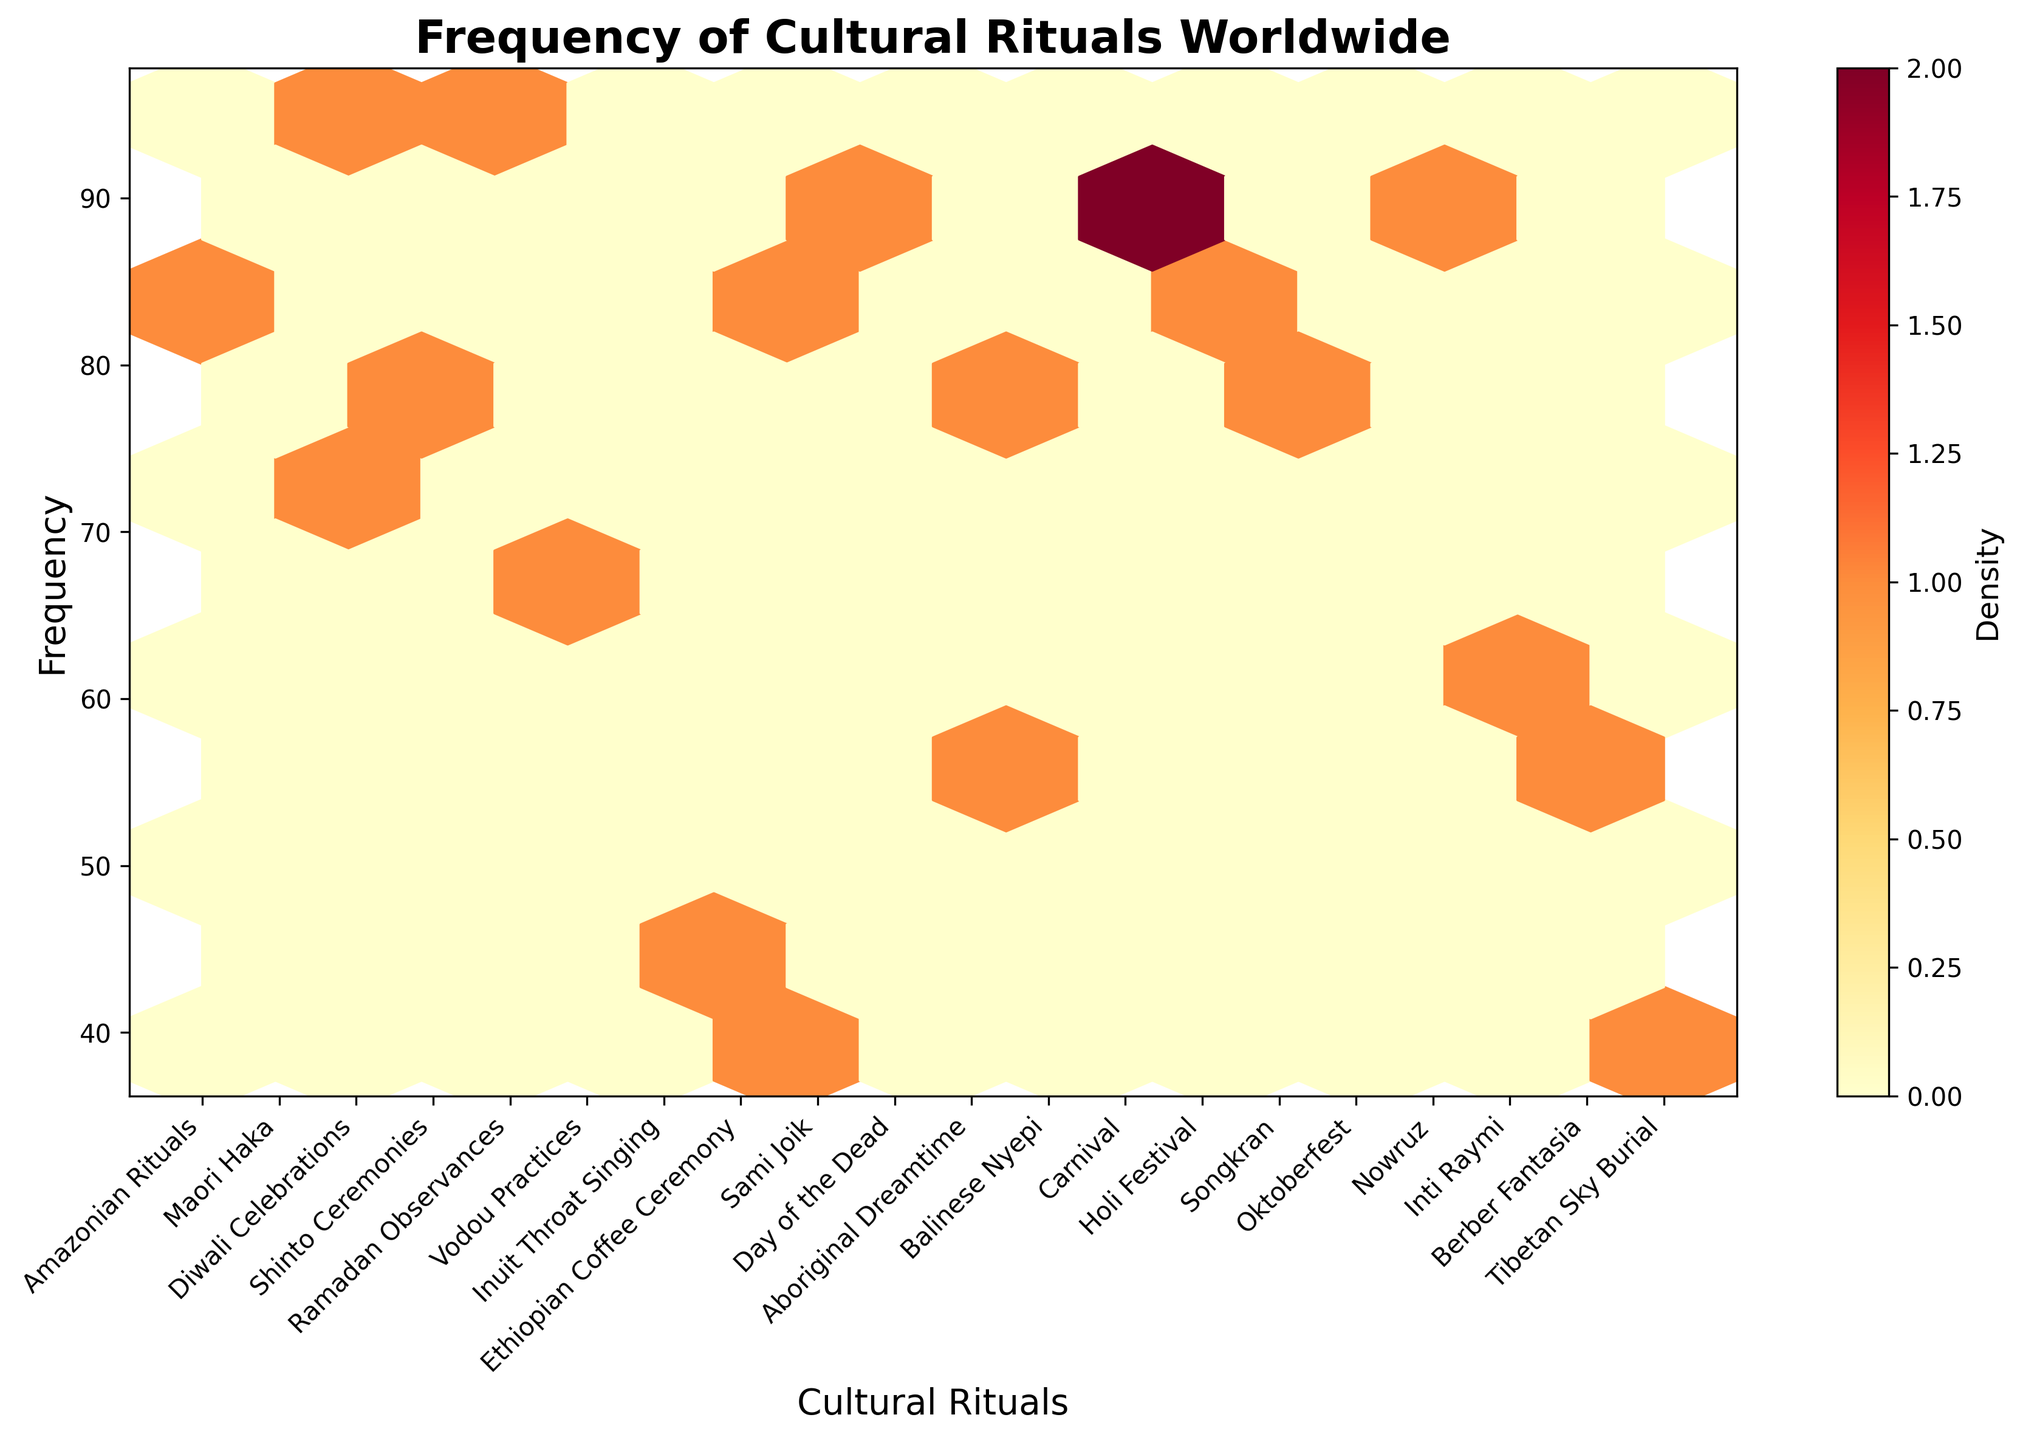what is the title of the plot? The plot has a title positioned at the top, which helps the viewer understand the purpose of the visualization.
Answer: Frequency of Cultural Rituals Worldwide which cultural ritual has the highest frequency? The frequency of each cultural ritual is plotted on the y-axis. By looking at the highest point on this axis, we can identify the cultural ritual with the highest frequency.
Answer: Diwali Celebrations how many rituals have a frequency greater than 80? You need to count all the cultural rituals whose y-values (frequencies) are greater than 80. These are represented as points above the y=80 line on the plot.
Answer: 9 what is the frequency difference between the Maori Haka and Inuit Throat Singing? To find the difference, first identify the y-values (frequencies) for both rituals, then subtract the smaller value from the larger value. Maori Haka has a frequency of 72 and Inuit Throat Singing has a frequency of 45; so the difference is 72 - 45.
Answer: 27 which cultural rituals are represented from Oceania, and what are their frequencies? From the xtick labels, identify the rituals associated with Oceania and then note their frequencies from the y-axis.
Answer: Maori Haka (72) and Aboriginal Dreamtime (57) how does the frequency of 'Vodou Practices' compare to 'Day of the Dead'? Identify the y-values (frequencies) for both rituals. Vodou Practices have a frequency of 68 and Day of the Dead has a frequency of 88. Comparatively, Day of the Dead has a higher frequency.
Answer: Day of the Dead has a higher frequency than Vodou Practices what is the average frequency of Central Asia's and Middle East's rituals? Identify the frequencies for Central Asia's and Middle East's rituals from the xtick labels and y-values, then sum them up and divide by the number of rituals. Nowruz (86), Tibetan Sky Burial (41), and Ramadan Observances (93). The average is (86 + 41 + 93) / 3.
Answer: 73.33 among South American rituals, which one has the lowest frequency? Identify the xtick labels corresponding to South American rituals and compare their y-values (frequencies) to find the lowest one. South American rituals are: Amazonian Rituals (85), Carnival (91), and Inti Raymi (63).
Answer: Inti Raymi how clustered are the rituals with frequencies in the range of 70 to 90? In a Hexbin Plot, the density of the points is indicated by the color intensity. By observing the color intensity within the range of y-values 70 to 90, you can determine how clustered the rituals are. Look for darker colors within this range.
Answer: Moderately clustered which regions have more dense representation of rituals based on the color intensity? The regions correspond to different color intensities on the hexbin plot. Denser regions will have a more intense (darker) color. Observe the plot to see which regions exhibit these denser hexagons.
Answer: South America and South Asia 